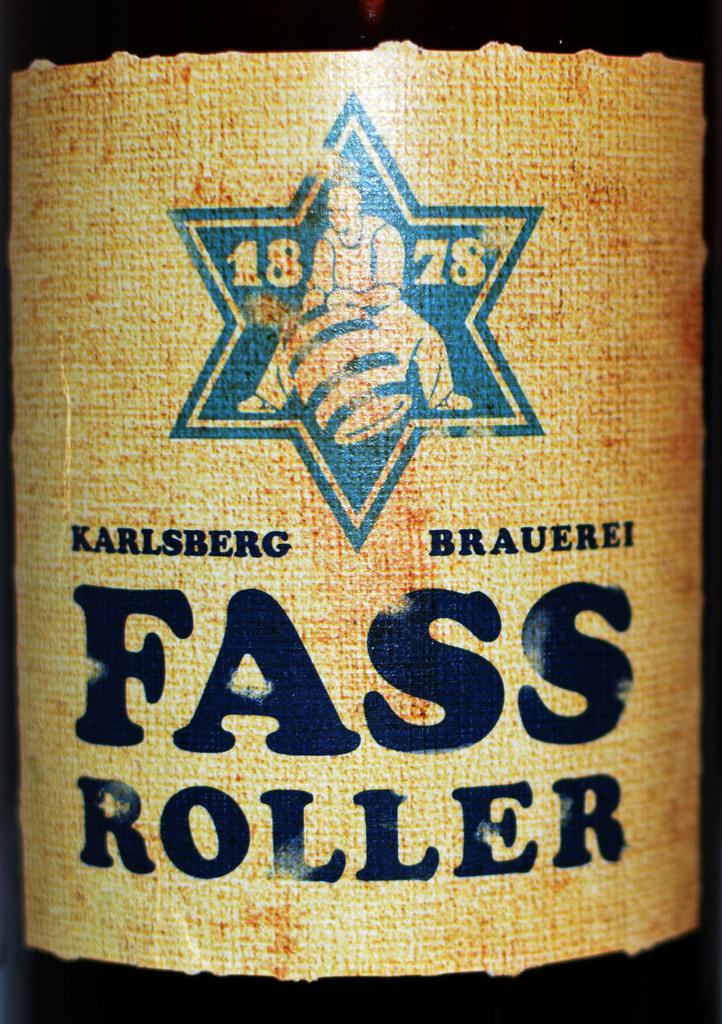<image>
Relay a brief, clear account of the picture shown. A drink in a bottle called Fass roller, founded in 1878 